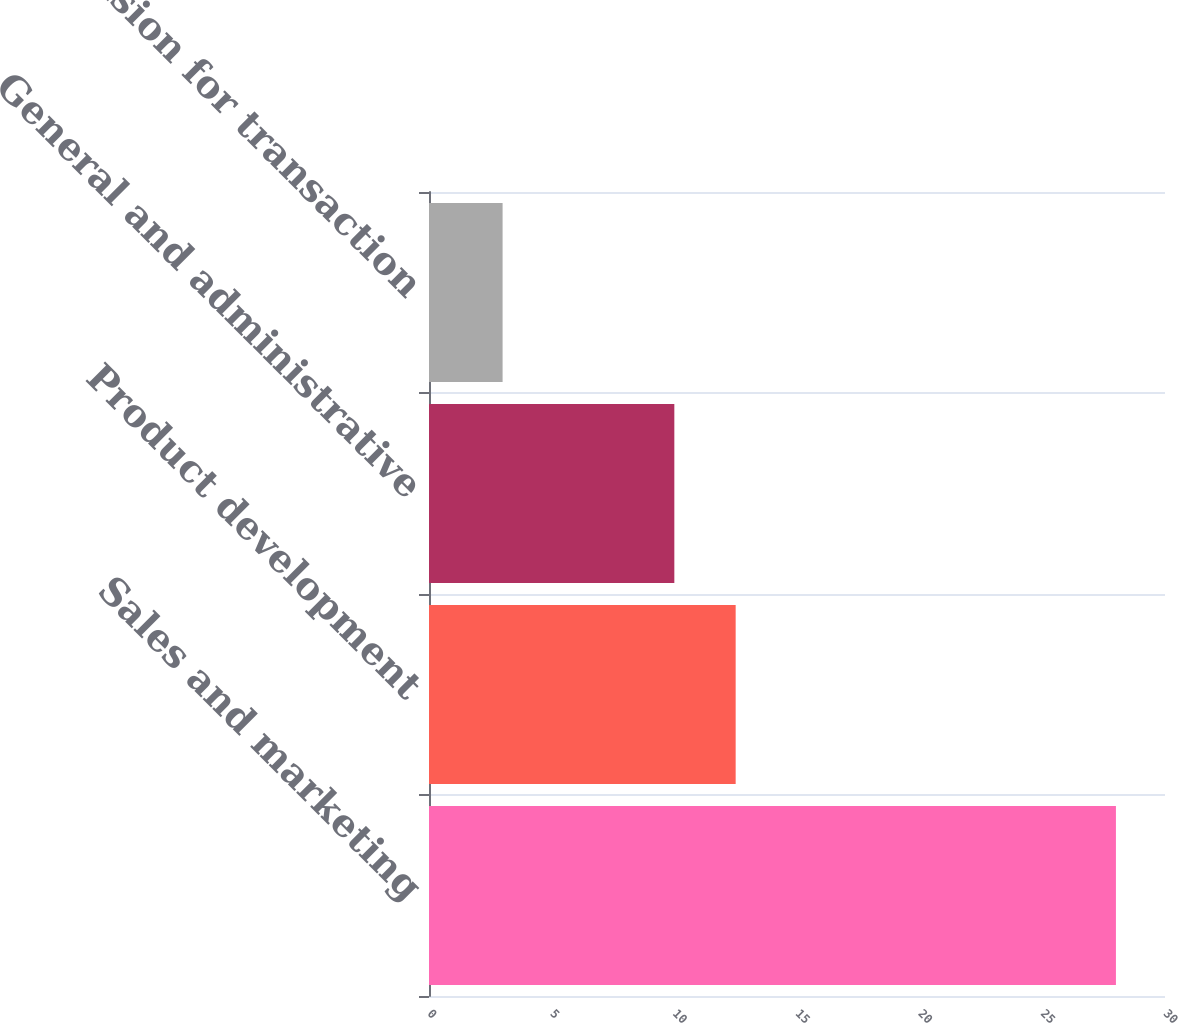<chart> <loc_0><loc_0><loc_500><loc_500><bar_chart><fcel>Sales and marketing<fcel>Product development<fcel>General and administrative<fcel>Provision for transaction<nl><fcel>28<fcel>12.5<fcel>10<fcel>3<nl></chart> 